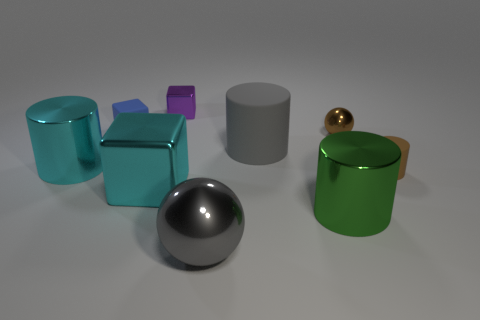How many other things are there of the same size as the blue matte block?
Your answer should be compact. 3. Do the brown matte thing and the shiny cylinder left of the tiny purple object have the same size?
Your response must be concise. No. What color is the other metallic cylinder that is the same size as the cyan cylinder?
Keep it short and to the point. Green. The cyan cylinder has what size?
Provide a succinct answer. Large. Are the small thing that is behind the small blue cube and the small brown cylinder made of the same material?
Provide a short and direct response. No. Is the shape of the brown shiny thing the same as the gray metallic thing?
Provide a short and direct response. Yes. What shape is the small metallic object on the left side of the large thing that is in front of the metal cylinder to the right of the tiny blue object?
Your response must be concise. Cube. There is a cyan thing to the right of the cyan shiny cylinder; is its shape the same as the rubber object to the left of the purple shiny cube?
Give a very brief answer. Yes. Is there a small brown cube that has the same material as the small blue thing?
Give a very brief answer. No. There is a ball that is behind the gray object in front of the big cyan metal cylinder on the left side of the brown matte cylinder; what color is it?
Your answer should be very brief. Brown. 